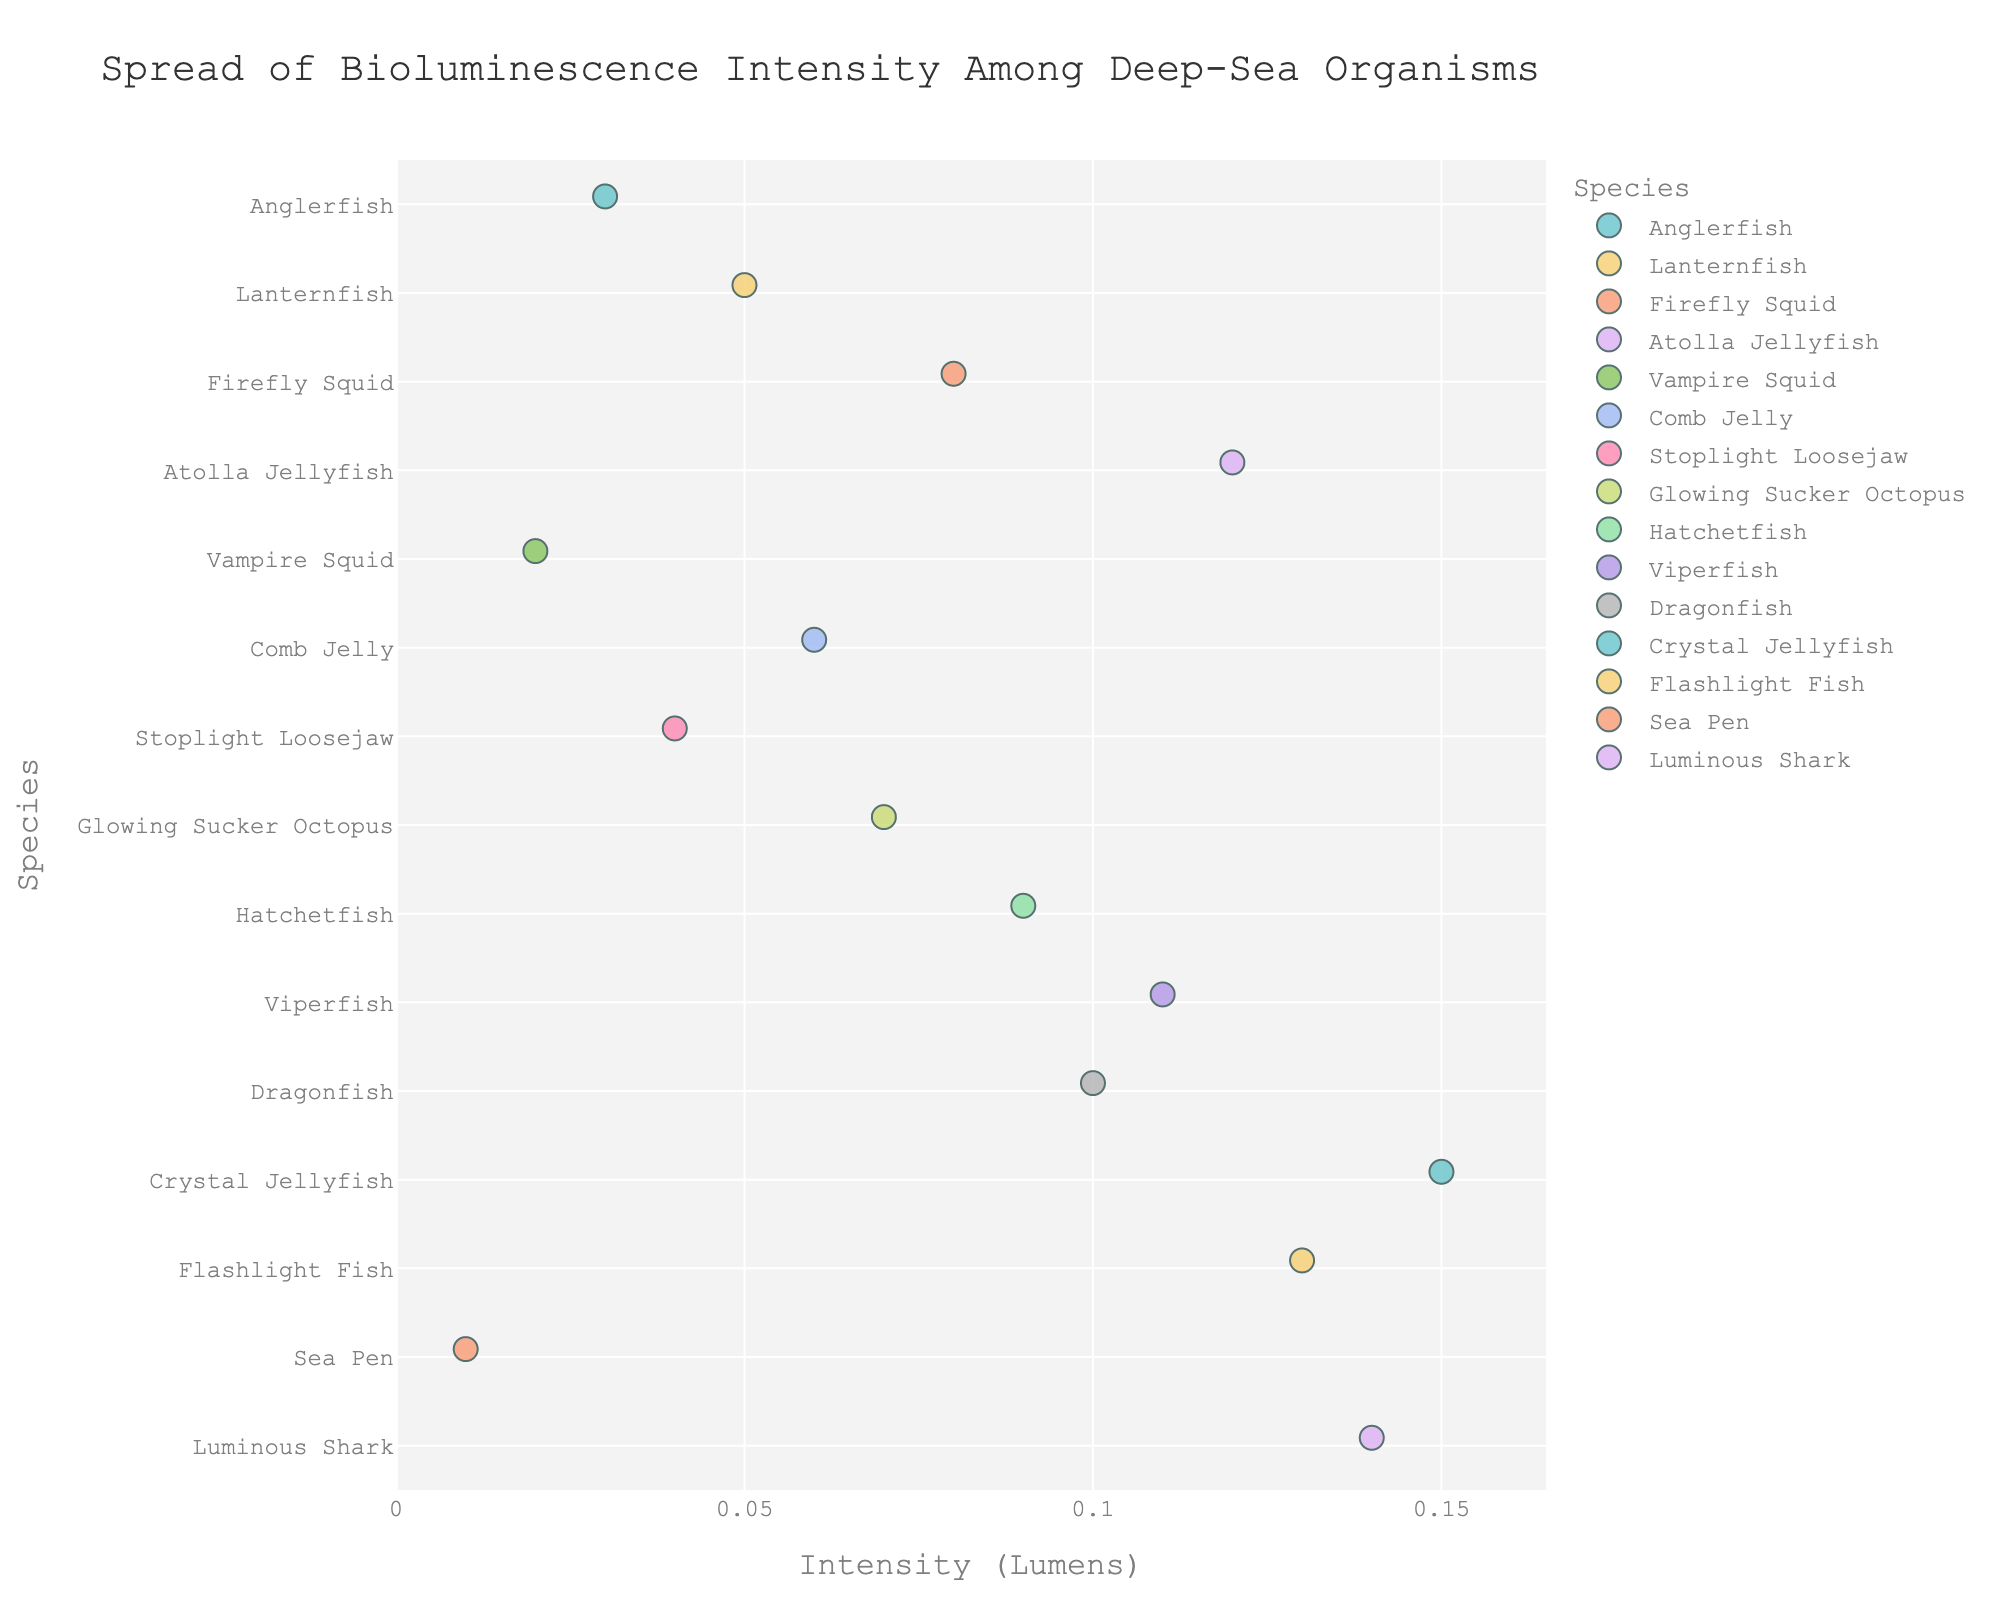What's the title of the strip plot? The title of the strip plot is provided at the top of the visualization for easy identification.
Answer: Spread of Bioluminescence Intensity Among Deep-Sea Organisms Which species has the highest bioluminescence intensity? To find the species with the highest bioluminescence intensity, look for the data point plotted farthest to the right on the x-axis.
Answer: Crystal Jellyfish Which species has the lowest bioluminescence intensity? The species with the lowest intensity is shown by the data point plotted farthest to the left on the x-axis.
Answer: Sea Pen How many species are represented in the strip plot? By counting the number of unique y-axis labels (species), we can determine the number of species represented.
Answer: 15 What is the bioluminescence intensity range in the plot? The range is the difference between the highest and lowest intensities. The highest intensity is 0.15, and the lowest is 0.01.
Answer: 0.14 Which species have a bioluminescence intensity greater than 0.10 lumens? Identify the data points to the right of the 0.10 mark on the x-axis and check their corresponding species.
Answer: Crystal Jellyfish, Flashlight Fish, Luminous Shark, Viperfish, Dragonfish Are there more species with bioluminescence intensity below 0.10 lumens or above 0.10 lumens? Count the species with intensity less than 0.10 and those with intensity greater than or equal to 0.10, then compare the counts.
Answer: Below 0.10 What's the average bioluminescence intensity across all species? Sum all the intensity values and divide by the number of species to get the average. (0.03 + 0.05 + 0.08 + 0.12 + 0.02 + 0.06 + 0.04 + 0.07 + 0.09 + 0.11 + 0.10 + 0.15 + 0.13 + 0.01 + 0.14) / 15 = 0.085
Answer: 0.085 Which species have bioluminescence intensity between 0.05 and 0.10 lumens, inclusive? Identify data points within the 0.05 to 0.10 range and check their corresponding species.
Answer: Lanternfish, Firefly Squid, Comb Jelly, Stoplight Loosejaw, Glowing Sucker Octopus, Hatchetfish Which species is used as the reference point for bioluminescence intensity in lumens? There is no explicit reference point species; however, all species' intensity values are compared against each other on the same scale on the x-axis.
Answer: N/A 